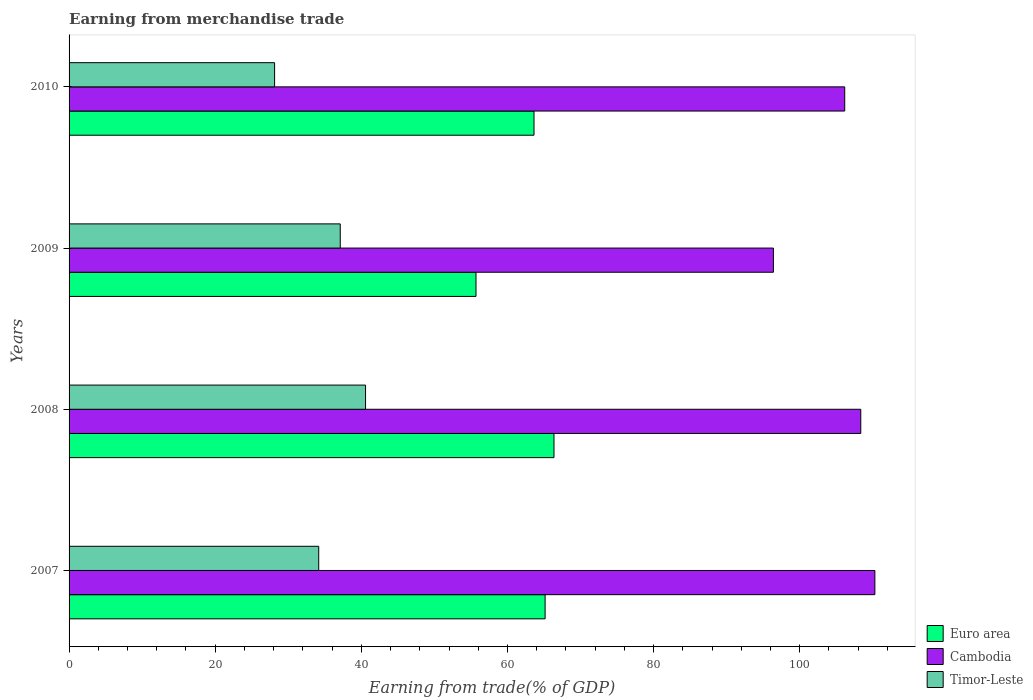How many bars are there on the 3rd tick from the top?
Give a very brief answer. 3. How many bars are there on the 1st tick from the bottom?
Provide a succinct answer. 3. In how many cases, is the number of bars for a given year not equal to the number of legend labels?
Your answer should be very brief. 0. What is the earnings from trade in Timor-Leste in 2009?
Provide a succinct answer. 37.11. Across all years, what is the maximum earnings from trade in Cambodia?
Your response must be concise. 110.28. Across all years, what is the minimum earnings from trade in Euro area?
Your answer should be compact. 55.69. What is the total earnings from trade in Cambodia in the graph?
Offer a terse response. 421.18. What is the difference between the earnings from trade in Cambodia in 2008 and that in 2010?
Offer a very short reply. 2.2. What is the difference between the earnings from trade in Cambodia in 2009 and the earnings from trade in Timor-Leste in 2008?
Your answer should be compact. 55.82. What is the average earnings from trade in Euro area per year?
Your answer should be very brief. 62.71. In the year 2010, what is the difference between the earnings from trade in Euro area and earnings from trade in Cambodia?
Ensure brevity in your answer.  -42.52. In how many years, is the earnings from trade in Cambodia greater than 48 %?
Ensure brevity in your answer.  4. What is the ratio of the earnings from trade in Timor-Leste in 2008 to that in 2009?
Keep it short and to the point. 1.09. Is the earnings from trade in Timor-Leste in 2007 less than that in 2009?
Give a very brief answer. Yes. What is the difference between the highest and the second highest earnings from trade in Euro area?
Offer a terse response. 1.21. What is the difference between the highest and the lowest earnings from trade in Euro area?
Offer a very short reply. 10.67. In how many years, is the earnings from trade in Timor-Leste greater than the average earnings from trade in Timor-Leste taken over all years?
Your answer should be very brief. 2. Is the sum of the earnings from trade in Timor-Leste in 2007 and 2009 greater than the maximum earnings from trade in Cambodia across all years?
Keep it short and to the point. No. What does the 3rd bar from the top in 2010 represents?
Ensure brevity in your answer.  Euro area. What does the 2nd bar from the bottom in 2010 represents?
Give a very brief answer. Cambodia. Is it the case that in every year, the sum of the earnings from trade in Euro area and earnings from trade in Cambodia is greater than the earnings from trade in Timor-Leste?
Keep it short and to the point. Yes. How many bars are there?
Your answer should be compact. 12. What is the difference between two consecutive major ticks on the X-axis?
Give a very brief answer. 20. Where does the legend appear in the graph?
Give a very brief answer. Bottom right. How many legend labels are there?
Offer a very short reply. 3. How are the legend labels stacked?
Ensure brevity in your answer.  Vertical. What is the title of the graph?
Your response must be concise. Earning from merchandise trade. Does "Venezuela" appear as one of the legend labels in the graph?
Make the answer very short. No. What is the label or title of the X-axis?
Provide a short and direct response. Earning from trade(% of GDP). What is the Earning from trade(% of GDP) of Euro area in 2007?
Make the answer very short. 65.15. What is the Earning from trade(% of GDP) of Cambodia in 2007?
Offer a very short reply. 110.28. What is the Earning from trade(% of GDP) in Timor-Leste in 2007?
Your response must be concise. 34.17. What is the Earning from trade(% of GDP) in Euro area in 2008?
Keep it short and to the point. 66.36. What is the Earning from trade(% of GDP) in Cambodia in 2008?
Offer a terse response. 108.35. What is the Earning from trade(% of GDP) of Timor-Leste in 2008?
Your answer should be compact. 40.57. What is the Earning from trade(% of GDP) of Euro area in 2009?
Keep it short and to the point. 55.69. What is the Earning from trade(% of GDP) of Cambodia in 2009?
Ensure brevity in your answer.  96.39. What is the Earning from trade(% of GDP) in Timor-Leste in 2009?
Make the answer very short. 37.11. What is the Earning from trade(% of GDP) of Euro area in 2010?
Make the answer very short. 63.63. What is the Earning from trade(% of GDP) in Cambodia in 2010?
Provide a short and direct response. 106.15. What is the Earning from trade(% of GDP) in Timor-Leste in 2010?
Offer a terse response. 28.13. Across all years, what is the maximum Earning from trade(% of GDP) of Euro area?
Your response must be concise. 66.36. Across all years, what is the maximum Earning from trade(% of GDP) in Cambodia?
Make the answer very short. 110.28. Across all years, what is the maximum Earning from trade(% of GDP) of Timor-Leste?
Make the answer very short. 40.57. Across all years, what is the minimum Earning from trade(% of GDP) of Euro area?
Offer a very short reply. 55.69. Across all years, what is the minimum Earning from trade(% of GDP) of Cambodia?
Provide a succinct answer. 96.39. Across all years, what is the minimum Earning from trade(% of GDP) of Timor-Leste?
Make the answer very short. 28.13. What is the total Earning from trade(% of GDP) of Euro area in the graph?
Your answer should be very brief. 250.84. What is the total Earning from trade(% of GDP) of Cambodia in the graph?
Provide a succinct answer. 421.18. What is the total Earning from trade(% of GDP) in Timor-Leste in the graph?
Offer a very short reply. 139.98. What is the difference between the Earning from trade(% of GDP) of Euro area in 2007 and that in 2008?
Your answer should be very brief. -1.21. What is the difference between the Earning from trade(% of GDP) in Cambodia in 2007 and that in 2008?
Your answer should be very brief. 1.93. What is the difference between the Earning from trade(% of GDP) in Timor-Leste in 2007 and that in 2008?
Provide a short and direct response. -6.41. What is the difference between the Earning from trade(% of GDP) in Euro area in 2007 and that in 2009?
Your answer should be compact. 9.46. What is the difference between the Earning from trade(% of GDP) of Cambodia in 2007 and that in 2009?
Offer a terse response. 13.89. What is the difference between the Earning from trade(% of GDP) in Timor-Leste in 2007 and that in 2009?
Keep it short and to the point. -2.95. What is the difference between the Earning from trade(% of GDP) in Euro area in 2007 and that in 2010?
Offer a terse response. 1.52. What is the difference between the Earning from trade(% of GDP) in Cambodia in 2007 and that in 2010?
Offer a very short reply. 4.13. What is the difference between the Earning from trade(% of GDP) in Timor-Leste in 2007 and that in 2010?
Ensure brevity in your answer.  6.04. What is the difference between the Earning from trade(% of GDP) in Euro area in 2008 and that in 2009?
Ensure brevity in your answer.  10.67. What is the difference between the Earning from trade(% of GDP) in Cambodia in 2008 and that in 2009?
Offer a very short reply. 11.96. What is the difference between the Earning from trade(% of GDP) in Timor-Leste in 2008 and that in 2009?
Your answer should be compact. 3.46. What is the difference between the Earning from trade(% of GDP) in Euro area in 2008 and that in 2010?
Ensure brevity in your answer.  2.73. What is the difference between the Earning from trade(% of GDP) of Cambodia in 2008 and that in 2010?
Ensure brevity in your answer.  2.2. What is the difference between the Earning from trade(% of GDP) in Timor-Leste in 2008 and that in 2010?
Provide a short and direct response. 12.45. What is the difference between the Earning from trade(% of GDP) in Euro area in 2009 and that in 2010?
Your answer should be very brief. -7.94. What is the difference between the Earning from trade(% of GDP) in Cambodia in 2009 and that in 2010?
Your response must be concise. -9.76. What is the difference between the Earning from trade(% of GDP) of Timor-Leste in 2009 and that in 2010?
Your response must be concise. 8.99. What is the difference between the Earning from trade(% of GDP) of Euro area in 2007 and the Earning from trade(% of GDP) of Cambodia in 2008?
Your answer should be very brief. -43.2. What is the difference between the Earning from trade(% of GDP) in Euro area in 2007 and the Earning from trade(% of GDP) in Timor-Leste in 2008?
Offer a terse response. 24.58. What is the difference between the Earning from trade(% of GDP) of Cambodia in 2007 and the Earning from trade(% of GDP) of Timor-Leste in 2008?
Make the answer very short. 69.71. What is the difference between the Earning from trade(% of GDP) of Euro area in 2007 and the Earning from trade(% of GDP) of Cambodia in 2009?
Provide a succinct answer. -31.24. What is the difference between the Earning from trade(% of GDP) in Euro area in 2007 and the Earning from trade(% of GDP) in Timor-Leste in 2009?
Offer a terse response. 28.04. What is the difference between the Earning from trade(% of GDP) of Cambodia in 2007 and the Earning from trade(% of GDP) of Timor-Leste in 2009?
Offer a terse response. 73.17. What is the difference between the Earning from trade(% of GDP) of Euro area in 2007 and the Earning from trade(% of GDP) of Cambodia in 2010?
Give a very brief answer. -41. What is the difference between the Earning from trade(% of GDP) in Euro area in 2007 and the Earning from trade(% of GDP) in Timor-Leste in 2010?
Your answer should be compact. 37.02. What is the difference between the Earning from trade(% of GDP) of Cambodia in 2007 and the Earning from trade(% of GDP) of Timor-Leste in 2010?
Your answer should be very brief. 82.15. What is the difference between the Earning from trade(% of GDP) in Euro area in 2008 and the Earning from trade(% of GDP) in Cambodia in 2009?
Make the answer very short. -30.03. What is the difference between the Earning from trade(% of GDP) of Euro area in 2008 and the Earning from trade(% of GDP) of Timor-Leste in 2009?
Provide a succinct answer. 29.25. What is the difference between the Earning from trade(% of GDP) in Cambodia in 2008 and the Earning from trade(% of GDP) in Timor-Leste in 2009?
Your answer should be very brief. 71.24. What is the difference between the Earning from trade(% of GDP) of Euro area in 2008 and the Earning from trade(% of GDP) of Cambodia in 2010?
Provide a succinct answer. -39.79. What is the difference between the Earning from trade(% of GDP) in Euro area in 2008 and the Earning from trade(% of GDP) in Timor-Leste in 2010?
Offer a very short reply. 38.24. What is the difference between the Earning from trade(% of GDP) in Cambodia in 2008 and the Earning from trade(% of GDP) in Timor-Leste in 2010?
Ensure brevity in your answer.  80.22. What is the difference between the Earning from trade(% of GDP) in Euro area in 2009 and the Earning from trade(% of GDP) in Cambodia in 2010?
Give a very brief answer. -50.46. What is the difference between the Earning from trade(% of GDP) in Euro area in 2009 and the Earning from trade(% of GDP) in Timor-Leste in 2010?
Offer a very short reply. 27.56. What is the difference between the Earning from trade(% of GDP) of Cambodia in 2009 and the Earning from trade(% of GDP) of Timor-Leste in 2010?
Ensure brevity in your answer.  68.27. What is the average Earning from trade(% of GDP) of Euro area per year?
Keep it short and to the point. 62.71. What is the average Earning from trade(% of GDP) of Cambodia per year?
Make the answer very short. 105.29. What is the average Earning from trade(% of GDP) in Timor-Leste per year?
Your response must be concise. 34.99. In the year 2007, what is the difference between the Earning from trade(% of GDP) in Euro area and Earning from trade(% of GDP) in Cambodia?
Your answer should be compact. -45.13. In the year 2007, what is the difference between the Earning from trade(% of GDP) of Euro area and Earning from trade(% of GDP) of Timor-Leste?
Ensure brevity in your answer.  30.98. In the year 2007, what is the difference between the Earning from trade(% of GDP) in Cambodia and Earning from trade(% of GDP) in Timor-Leste?
Your answer should be compact. 76.11. In the year 2008, what is the difference between the Earning from trade(% of GDP) of Euro area and Earning from trade(% of GDP) of Cambodia?
Provide a succinct answer. -41.99. In the year 2008, what is the difference between the Earning from trade(% of GDP) of Euro area and Earning from trade(% of GDP) of Timor-Leste?
Provide a succinct answer. 25.79. In the year 2008, what is the difference between the Earning from trade(% of GDP) in Cambodia and Earning from trade(% of GDP) in Timor-Leste?
Keep it short and to the point. 67.78. In the year 2009, what is the difference between the Earning from trade(% of GDP) in Euro area and Earning from trade(% of GDP) in Cambodia?
Your response must be concise. -40.7. In the year 2009, what is the difference between the Earning from trade(% of GDP) of Euro area and Earning from trade(% of GDP) of Timor-Leste?
Ensure brevity in your answer.  18.58. In the year 2009, what is the difference between the Earning from trade(% of GDP) in Cambodia and Earning from trade(% of GDP) in Timor-Leste?
Keep it short and to the point. 59.28. In the year 2010, what is the difference between the Earning from trade(% of GDP) of Euro area and Earning from trade(% of GDP) of Cambodia?
Offer a very short reply. -42.52. In the year 2010, what is the difference between the Earning from trade(% of GDP) of Euro area and Earning from trade(% of GDP) of Timor-Leste?
Provide a short and direct response. 35.5. In the year 2010, what is the difference between the Earning from trade(% of GDP) of Cambodia and Earning from trade(% of GDP) of Timor-Leste?
Ensure brevity in your answer.  78.03. What is the ratio of the Earning from trade(% of GDP) in Euro area in 2007 to that in 2008?
Your answer should be compact. 0.98. What is the ratio of the Earning from trade(% of GDP) in Cambodia in 2007 to that in 2008?
Give a very brief answer. 1.02. What is the ratio of the Earning from trade(% of GDP) of Timor-Leste in 2007 to that in 2008?
Provide a short and direct response. 0.84. What is the ratio of the Earning from trade(% of GDP) in Euro area in 2007 to that in 2009?
Offer a terse response. 1.17. What is the ratio of the Earning from trade(% of GDP) of Cambodia in 2007 to that in 2009?
Make the answer very short. 1.14. What is the ratio of the Earning from trade(% of GDP) of Timor-Leste in 2007 to that in 2009?
Ensure brevity in your answer.  0.92. What is the ratio of the Earning from trade(% of GDP) of Euro area in 2007 to that in 2010?
Give a very brief answer. 1.02. What is the ratio of the Earning from trade(% of GDP) in Cambodia in 2007 to that in 2010?
Your answer should be very brief. 1.04. What is the ratio of the Earning from trade(% of GDP) in Timor-Leste in 2007 to that in 2010?
Your response must be concise. 1.21. What is the ratio of the Earning from trade(% of GDP) in Euro area in 2008 to that in 2009?
Provide a succinct answer. 1.19. What is the ratio of the Earning from trade(% of GDP) in Cambodia in 2008 to that in 2009?
Keep it short and to the point. 1.12. What is the ratio of the Earning from trade(% of GDP) of Timor-Leste in 2008 to that in 2009?
Your response must be concise. 1.09. What is the ratio of the Earning from trade(% of GDP) of Euro area in 2008 to that in 2010?
Offer a very short reply. 1.04. What is the ratio of the Earning from trade(% of GDP) in Cambodia in 2008 to that in 2010?
Your response must be concise. 1.02. What is the ratio of the Earning from trade(% of GDP) in Timor-Leste in 2008 to that in 2010?
Ensure brevity in your answer.  1.44. What is the ratio of the Earning from trade(% of GDP) of Euro area in 2009 to that in 2010?
Your answer should be very brief. 0.88. What is the ratio of the Earning from trade(% of GDP) of Cambodia in 2009 to that in 2010?
Make the answer very short. 0.91. What is the ratio of the Earning from trade(% of GDP) in Timor-Leste in 2009 to that in 2010?
Provide a succinct answer. 1.32. What is the difference between the highest and the second highest Earning from trade(% of GDP) in Euro area?
Offer a terse response. 1.21. What is the difference between the highest and the second highest Earning from trade(% of GDP) in Cambodia?
Your answer should be very brief. 1.93. What is the difference between the highest and the second highest Earning from trade(% of GDP) in Timor-Leste?
Your answer should be very brief. 3.46. What is the difference between the highest and the lowest Earning from trade(% of GDP) of Euro area?
Provide a short and direct response. 10.67. What is the difference between the highest and the lowest Earning from trade(% of GDP) in Cambodia?
Your answer should be very brief. 13.89. What is the difference between the highest and the lowest Earning from trade(% of GDP) of Timor-Leste?
Your answer should be compact. 12.45. 